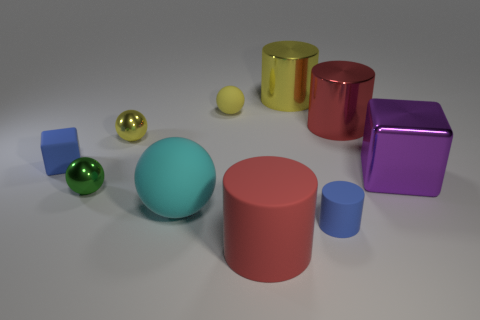The tiny metallic thing behind the tiny blue matte object to the left of the blue matte cylinder right of the small green sphere is what shape?
Your response must be concise. Sphere. There is a metal thing that is both in front of the matte block and on the left side of the large yellow thing; what is its color?
Offer a very short reply. Green. There is a small blue object that is to the right of the small green thing; what is its shape?
Provide a succinct answer. Cylinder. The green thing that is made of the same material as the purple block is what shape?
Offer a terse response. Sphere. How many rubber objects are green spheres or big green cubes?
Offer a very short reply. 0. There is a large metallic thing that is in front of the shiny cylinder that is right of the big yellow cylinder; how many big purple objects are left of it?
Offer a terse response. 0. There is a yellow sphere that is to the right of the big cyan matte thing; does it have the same size as the red cylinder that is behind the big purple cube?
Your answer should be compact. No. There is a large cyan object that is the same shape as the green metallic thing; what is it made of?
Keep it short and to the point. Rubber. What number of large things are either blue matte cylinders or brown matte spheres?
Offer a terse response. 0. What material is the blue cylinder?
Offer a very short reply. Rubber. 